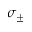<formula> <loc_0><loc_0><loc_500><loc_500>\sigma _ { \pm }</formula> 